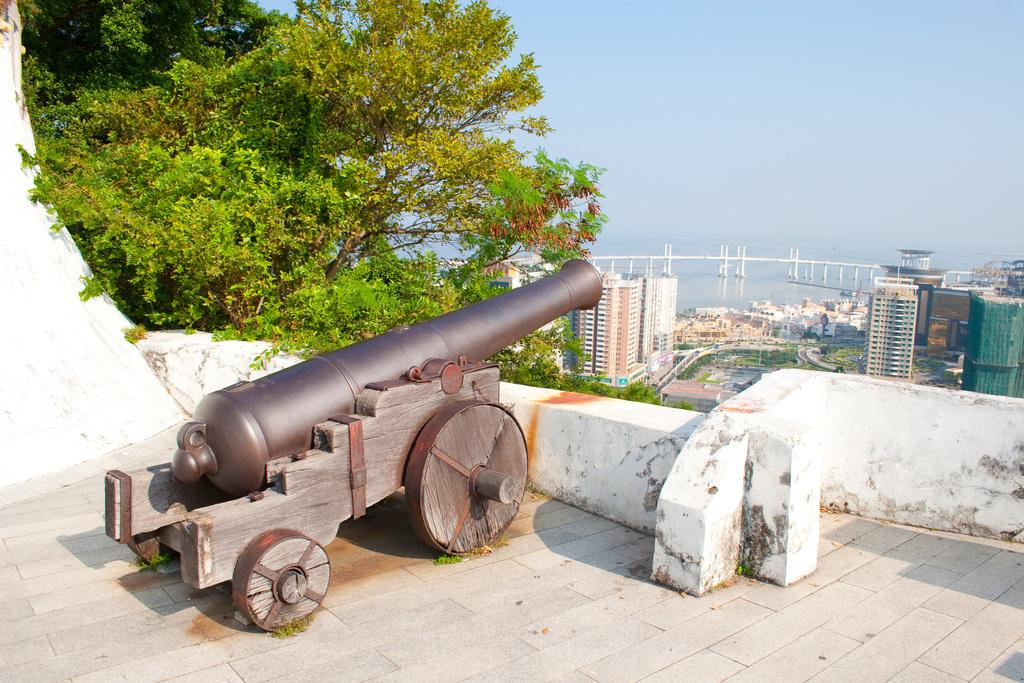What is the main object in the image? There is a cannon in the image. What is behind the cannon? There is a wall behind the cannon. What can be seen in the background of the image? There are trees, buildings, a bridge, and water visible in the background of the image. What is visible at the top of the image? The sky is visible at the top of the image. How does the cannon increase the belief in the image? The cannon does not increase or decrease belief in the image; it is simply an object present in the scene. 